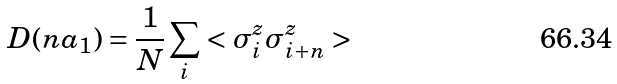<formula> <loc_0><loc_0><loc_500><loc_500>D ( n { a } _ { 1 } ) = \frac { 1 } { N } \sum _ { i } < \sigma ^ { z } _ { i } \sigma ^ { z } _ { i + n } ></formula> 